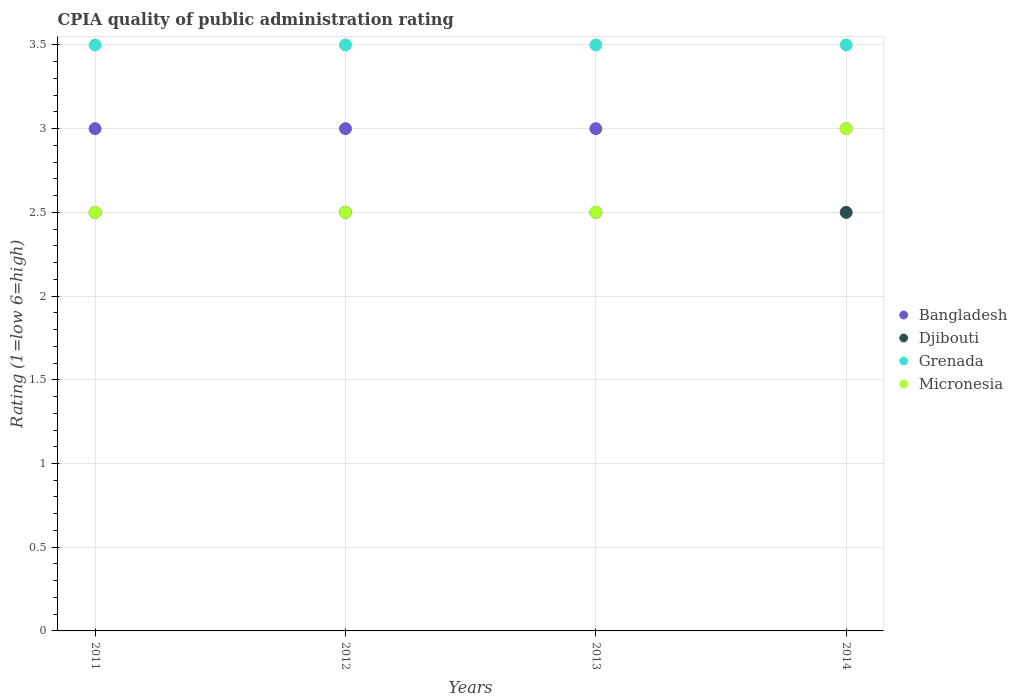Across all years, what is the maximum CPIA rating in Djibouti?
Offer a very short reply. 2.5. Across all years, what is the minimum CPIA rating in Micronesia?
Give a very brief answer. 2.5. In which year was the CPIA rating in Bangladesh maximum?
Offer a terse response. 2011. In which year was the CPIA rating in Grenada minimum?
Provide a short and direct response. 2011. What is the total CPIA rating in Bangladesh in the graph?
Offer a terse response. 12. What is the difference between the CPIA rating in Grenada in 2011 and the CPIA rating in Micronesia in 2012?
Provide a succinct answer. 1. What is the average CPIA rating in Bangladesh per year?
Your answer should be very brief. 3. In the year 2011, what is the difference between the CPIA rating in Micronesia and CPIA rating in Bangladesh?
Make the answer very short. -0.5. What is the ratio of the CPIA rating in Bangladesh in 2011 to that in 2012?
Offer a very short reply. 1. Is the difference between the CPIA rating in Micronesia in 2011 and 2014 greater than the difference between the CPIA rating in Bangladesh in 2011 and 2014?
Your answer should be compact. No. What is the difference between the highest and the second highest CPIA rating in Grenada?
Your answer should be compact. 0. Is the sum of the CPIA rating in Micronesia in 2012 and 2013 greater than the maximum CPIA rating in Djibouti across all years?
Keep it short and to the point. Yes. Is it the case that in every year, the sum of the CPIA rating in Micronesia and CPIA rating in Bangladesh  is greater than the CPIA rating in Djibouti?
Offer a terse response. Yes. Does the CPIA rating in Grenada monotonically increase over the years?
Your response must be concise. No. Is the CPIA rating in Grenada strictly greater than the CPIA rating in Bangladesh over the years?
Provide a short and direct response. Yes. How many dotlines are there?
Your answer should be compact. 4. How many years are there in the graph?
Your answer should be compact. 4. Are the values on the major ticks of Y-axis written in scientific E-notation?
Keep it short and to the point. No. Does the graph contain grids?
Keep it short and to the point. Yes. What is the title of the graph?
Provide a succinct answer. CPIA quality of public administration rating. What is the label or title of the X-axis?
Provide a succinct answer. Years. What is the label or title of the Y-axis?
Your answer should be very brief. Rating (1=low 6=high). What is the Rating (1=low 6=high) in Bangladesh in 2011?
Keep it short and to the point. 3. What is the Rating (1=low 6=high) in Djibouti in 2011?
Give a very brief answer. 2.5. What is the Rating (1=low 6=high) in Micronesia in 2011?
Make the answer very short. 2.5. What is the Rating (1=low 6=high) of Bangladesh in 2012?
Your answer should be compact. 3. What is the Rating (1=low 6=high) in Djibouti in 2012?
Ensure brevity in your answer.  2.5. What is the Rating (1=low 6=high) in Grenada in 2012?
Your answer should be compact. 3.5. What is the Rating (1=low 6=high) in Djibouti in 2013?
Offer a very short reply. 2.5. What is the Rating (1=low 6=high) of Grenada in 2013?
Your answer should be very brief. 3.5. What is the Rating (1=low 6=high) of Micronesia in 2013?
Offer a very short reply. 2.5. What is the Rating (1=low 6=high) of Grenada in 2014?
Offer a terse response. 3.5. What is the Rating (1=low 6=high) of Micronesia in 2014?
Provide a succinct answer. 3. Across all years, what is the maximum Rating (1=low 6=high) of Djibouti?
Ensure brevity in your answer.  2.5. Across all years, what is the maximum Rating (1=low 6=high) of Micronesia?
Your response must be concise. 3. Across all years, what is the minimum Rating (1=low 6=high) in Grenada?
Make the answer very short. 3.5. What is the total Rating (1=low 6=high) in Bangladesh in the graph?
Provide a short and direct response. 12. What is the total Rating (1=low 6=high) in Grenada in the graph?
Make the answer very short. 14. What is the total Rating (1=low 6=high) of Micronesia in the graph?
Your response must be concise. 10.5. What is the difference between the Rating (1=low 6=high) in Bangladesh in 2011 and that in 2012?
Your answer should be compact. 0. What is the difference between the Rating (1=low 6=high) of Djibouti in 2011 and that in 2012?
Provide a short and direct response. 0. What is the difference between the Rating (1=low 6=high) in Grenada in 2011 and that in 2012?
Give a very brief answer. 0. What is the difference between the Rating (1=low 6=high) in Micronesia in 2011 and that in 2012?
Your answer should be compact. 0. What is the difference between the Rating (1=low 6=high) in Djibouti in 2011 and that in 2013?
Your response must be concise. 0. What is the difference between the Rating (1=low 6=high) of Grenada in 2011 and that in 2013?
Your response must be concise. 0. What is the difference between the Rating (1=low 6=high) of Bangladesh in 2011 and that in 2014?
Keep it short and to the point. 0. What is the difference between the Rating (1=low 6=high) of Grenada in 2011 and that in 2014?
Provide a succinct answer. 0. What is the difference between the Rating (1=low 6=high) in Micronesia in 2011 and that in 2014?
Give a very brief answer. -0.5. What is the difference between the Rating (1=low 6=high) of Bangladesh in 2012 and that in 2013?
Provide a succinct answer. 0. What is the difference between the Rating (1=low 6=high) of Djibouti in 2012 and that in 2013?
Your answer should be very brief. 0. What is the difference between the Rating (1=low 6=high) in Micronesia in 2012 and that in 2013?
Keep it short and to the point. 0. What is the difference between the Rating (1=low 6=high) of Bangladesh in 2012 and that in 2014?
Offer a very short reply. 0. What is the difference between the Rating (1=low 6=high) of Grenada in 2012 and that in 2014?
Offer a very short reply. 0. What is the difference between the Rating (1=low 6=high) of Micronesia in 2012 and that in 2014?
Your answer should be very brief. -0.5. What is the difference between the Rating (1=low 6=high) in Micronesia in 2013 and that in 2014?
Make the answer very short. -0.5. What is the difference between the Rating (1=low 6=high) of Bangladesh in 2011 and the Rating (1=low 6=high) of Djibouti in 2012?
Your answer should be very brief. 0.5. What is the difference between the Rating (1=low 6=high) in Djibouti in 2011 and the Rating (1=low 6=high) in Micronesia in 2012?
Your answer should be compact. 0. What is the difference between the Rating (1=low 6=high) of Grenada in 2011 and the Rating (1=low 6=high) of Micronesia in 2012?
Offer a very short reply. 1. What is the difference between the Rating (1=low 6=high) in Bangladesh in 2011 and the Rating (1=low 6=high) in Djibouti in 2013?
Your response must be concise. 0.5. What is the difference between the Rating (1=low 6=high) of Bangladesh in 2011 and the Rating (1=low 6=high) of Micronesia in 2013?
Offer a terse response. 0.5. What is the difference between the Rating (1=low 6=high) in Djibouti in 2011 and the Rating (1=low 6=high) in Micronesia in 2013?
Keep it short and to the point. 0. What is the difference between the Rating (1=low 6=high) in Grenada in 2011 and the Rating (1=low 6=high) in Micronesia in 2013?
Provide a succinct answer. 1. What is the difference between the Rating (1=low 6=high) of Bangladesh in 2011 and the Rating (1=low 6=high) of Djibouti in 2014?
Provide a succinct answer. 0.5. What is the difference between the Rating (1=low 6=high) in Bangladesh in 2011 and the Rating (1=low 6=high) in Micronesia in 2014?
Your answer should be compact. 0. What is the difference between the Rating (1=low 6=high) of Djibouti in 2011 and the Rating (1=low 6=high) of Grenada in 2014?
Offer a terse response. -1. What is the difference between the Rating (1=low 6=high) in Djibouti in 2011 and the Rating (1=low 6=high) in Micronesia in 2014?
Offer a terse response. -0.5. What is the difference between the Rating (1=low 6=high) of Grenada in 2011 and the Rating (1=low 6=high) of Micronesia in 2014?
Your answer should be very brief. 0.5. What is the difference between the Rating (1=low 6=high) in Bangladesh in 2012 and the Rating (1=low 6=high) in Djibouti in 2013?
Provide a short and direct response. 0.5. What is the difference between the Rating (1=low 6=high) of Bangladesh in 2012 and the Rating (1=low 6=high) of Grenada in 2013?
Provide a short and direct response. -0.5. What is the difference between the Rating (1=low 6=high) of Bangladesh in 2012 and the Rating (1=low 6=high) of Micronesia in 2013?
Your response must be concise. 0.5. What is the difference between the Rating (1=low 6=high) in Djibouti in 2012 and the Rating (1=low 6=high) in Grenada in 2013?
Provide a short and direct response. -1. What is the difference between the Rating (1=low 6=high) of Bangladesh in 2012 and the Rating (1=low 6=high) of Grenada in 2014?
Give a very brief answer. -0.5. What is the difference between the Rating (1=low 6=high) in Djibouti in 2012 and the Rating (1=low 6=high) in Micronesia in 2014?
Keep it short and to the point. -0.5. What is the difference between the Rating (1=low 6=high) of Grenada in 2012 and the Rating (1=low 6=high) of Micronesia in 2014?
Offer a very short reply. 0.5. What is the difference between the Rating (1=low 6=high) of Bangladesh in 2013 and the Rating (1=low 6=high) of Djibouti in 2014?
Offer a very short reply. 0.5. What is the difference between the Rating (1=low 6=high) of Bangladesh in 2013 and the Rating (1=low 6=high) of Micronesia in 2014?
Provide a succinct answer. 0. What is the difference between the Rating (1=low 6=high) in Djibouti in 2013 and the Rating (1=low 6=high) in Grenada in 2014?
Your response must be concise. -1. What is the average Rating (1=low 6=high) of Djibouti per year?
Ensure brevity in your answer.  2.5. What is the average Rating (1=low 6=high) of Micronesia per year?
Ensure brevity in your answer.  2.62. In the year 2011, what is the difference between the Rating (1=low 6=high) of Bangladesh and Rating (1=low 6=high) of Djibouti?
Offer a very short reply. 0.5. In the year 2011, what is the difference between the Rating (1=low 6=high) of Bangladesh and Rating (1=low 6=high) of Grenada?
Your answer should be very brief. -0.5. In the year 2011, what is the difference between the Rating (1=low 6=high) of Djibouti and Rating (1=low 6=high) of Micronesia?
Provide a succinct answer. 0. In the year 2011, what is the difference between the Rating (1=low 6=high) of Grenada and Rating (1=low 6=high) of Micronesia?
Offer a very short reply. 1. In the year 2012, what is the difference between the Rating (1=low 6=high) in Bangladesh and Rating (1=low 6=high) in Djibouti?
Keep it short and to the point. 0.5. In the year 2012, what is the difference between the Rating (1=low 6=high) in Bangladesh and Rating (1=low 6=high) in Grenada?
Ensure brevity in your answer.  -0.5. In the year 2013, what is the difference between the Rating (1=low 6=high) of Bangladesh and Rating (1=low 6=high) of Djibouti?
Provide a succinct answer. 0.5. In the year 2013, what is the difference between the Rating (1=low 6=high) of Djibouti and Rating (1=low 6=high) of Grenada?
Provide a short and direct response. -1. In the year 2013, what is the difference between the Rating (1=low 6=high) in Grenada and Rating (1=low 6=high) in Micronesia?
Offer a very short reply. 1. In the year 2014, what is the difference between the Rating (1=low 6=high) of Djibouti and Rating (1=low 6=high) of Micronesia?
Offer a terse response. -0.5. What is the ratio of the Rating (1=low 6=high) of Bangladesh in 2011 to that in 2012?
Your response must be concise. 1. What is the ratio of the Rating (1=low 6=high) of Grenada in 2011 to that in 2012?
Ensure brevity in your answer.  1. What is the ratio of the Rating (1=low 6=high) in Micronesia in 2011 to that in 2014?
Give a very brief answer. 0.83. What is the ratio of the Rating (1=low 6=high) of Bangladesh in 2012 to that in 2013?
Provide a short and direct response. 1. What is the ratio of the Rating (1=low 6=high) in Grenada in 2012 to that in 2013?
Make the answer very short. 1. What is the ratio of the Rating (1=low 6=high) in Micronesia in 2012 to that in 2013?
Your response must be concise. 1. What is the ratio of the Rating (1=low 6=high) of Bangladesh in 2012 to that in 2014?
Offer a very short reply. 1. What is the ratio of the Rating (1=low 6=high) of Micronesia in 2012 to that in 2014?
Provide a succinct answer. 0.83. What is the difference between the highest and the second highest Rating (1=low 6=high) in Micronesia?
Offer a terse response. 0.5. What is the difference between the highest and the lowest Rating (1=low 6=high) of Bangladesh?
Keep it short and to the point. 0. What is the difference between the highest and the lowest Rating (1=low 6=high) of Djibouti?
Keep it short and to the point. 0. What is the difference between the highest and the lowest Rating (1=low 6=high) of Micronesia?
Offer a terse response. 0.5. 